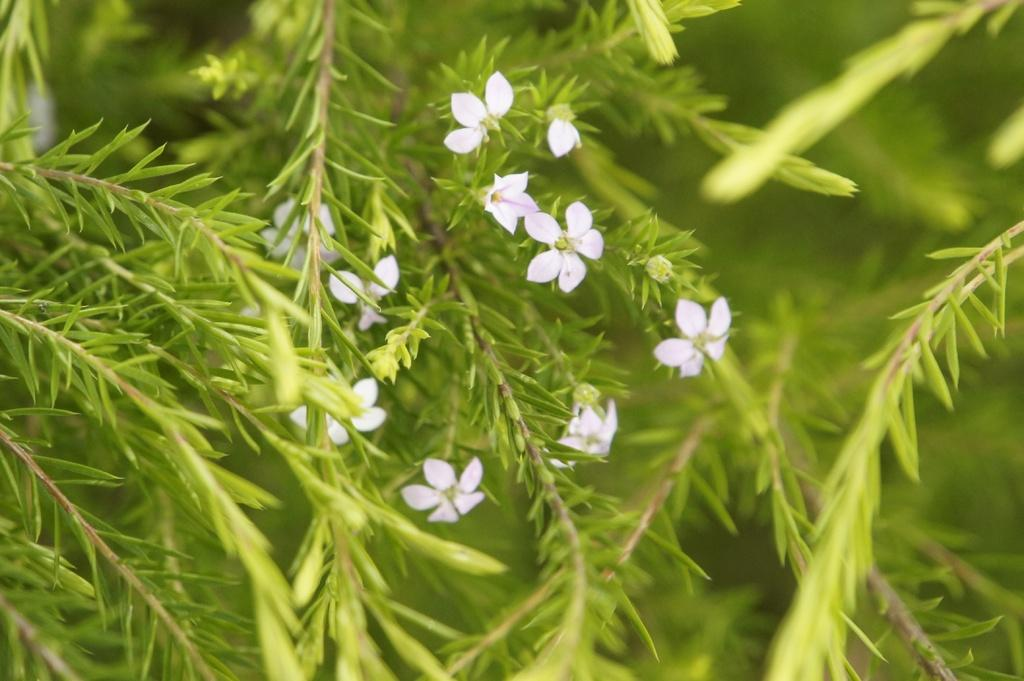What type of flora can be seen in the image? There are flowers in the image. What color are the flowers? The flowers are white in color. What other type of plant is present in the image? There is a plant in the image. What color is the plant? The plant is green in color. How many heads of lettuce can be seen in the image? There is no lettuce present in the image; it features flowers and a plant. What type of sink is visible in the image? There is no sink present in the image. 